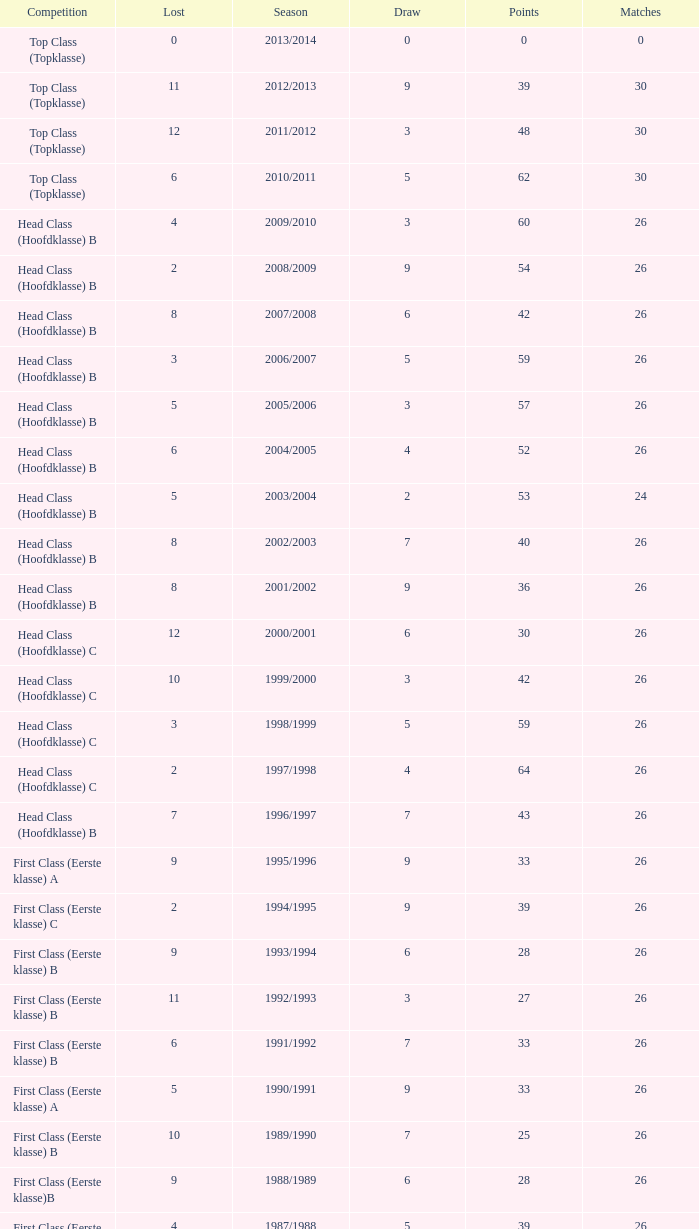What competition has a score greater than 30, a draw less than 5, and a loss larger than 10? Top Class (Topklasse). 